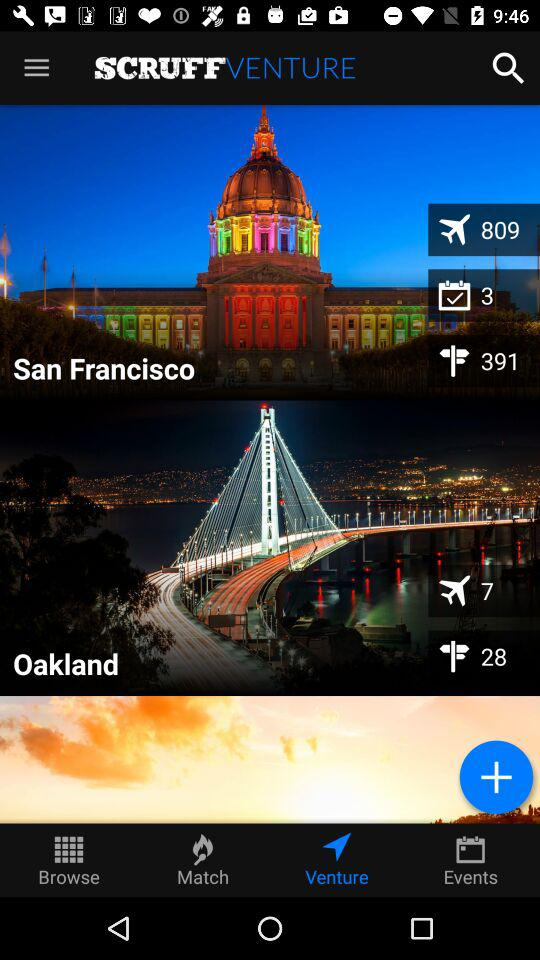What is the number of flights that depart from Oakland? The number of flights that depart from Oakland is 7. 